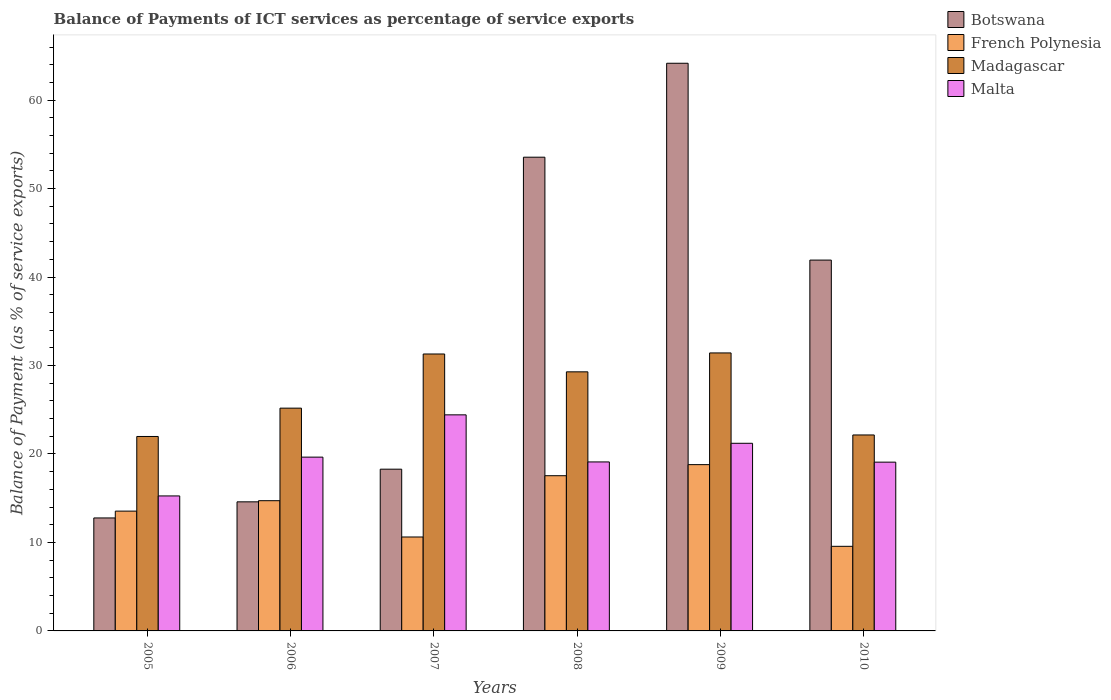How many different coloured bars are there?
Ensure brevity in your answer.  4. How many groups of bars are there?
Ensure brevity in your answer.  6. Are the number of bars per tick equal to the number of legend labels?
Provide a short and direct response. Yes. Are the number of bars on each tick of the X-axis equal?
Keep it short and to the point. Yes. How many bars are there on the 3rd tick from the left?
Provide a short and direct response. 4. What is the label of the 4th group of bars from the left?
Keep it short and to the point. 2008. In how many cases, is the number of bars for a given year not equal to the number of legend labels?
Offer a terse response. 0. What is the balance of payments of ICT services in Malta in 2007?
Ensure brevity in your answer.  24.42. Across all years, what is the maximum balance of payments of ICT services in Botswana?
Provide a short and direct response. 64.16. Across all years, what is the minimum balance of payments of ICT services in Madagascar?
Ensure brevity in your answer.  21.98. In which year was the balance of payments of ICT services in Madagascar minimum?
Provide a short and direct response. 2005. What is the total balance of payments of ICT services in French Polynesia in the graph?
Provide a short and direct response. 84.78. What is the difference between the balance of payments of ICT services in Botswana in 2005 and that in 2008?
Provide a short and direct response. -40.77. What is the difference between the balance of payments of ICT services in Botswana in 2008 and the balance of payments of ICT services in Malta in 2005?
Offer a very short reply. 38.29. What is the average balance of payments of ICT services in Madagascar per year?
Ensure brevity in your answer.  26.89. In the year 2006, what is the difference between the balance of payments of ICT services in Madagascar and balance of payments of ICT services in Botswana?
Your answer should be compact. 10.59. What is the ratio of the balance of payments of ICT services in Malta in 2005 to that in 2008?
Your answer should be very brief. 0.8. What is the difference between the highest and the second highest balance of payments of ICT services in Botswana?
Your answer should be very brief. 10.62. What is the difference between the highest and the lowest balance of payments of ICT services in Botswana?
Keep it short and to the point. 51.39. In how many years, is the balance of payments of ICT services in French Polynesia greater than the average balance of payments of ICT services in French Polynesia taken over all years?
Make the answer very short. 3. Is the sum of the balance of payments of ICT services in French Polynesia in 2007 and 2009 greater than the maximum balance of payments of ICT services in Botswana across all years?
Your response must be concise. No. What does the 1st bar from the left in 2007 represents?
Make the answer very short. Botswana. What does the 3rd bar from the right in 2005 represents?
Give a very brief answer. French Polynesia. How many bars are there?
Your answer should be very brief. 24. Are all the bars in the graph horizontal?
Provide a succinct answer. No. How many years are there in the graph?
Keep it short and to the point. 6. What is the difference between two consecutive major ticks on the Y-axis?
Ensure brevity in your answer.  10. Does the graph contain any zero values?
Make the answer very short. No. How are the legend labels stacked?
Provide a succinct answer. Vertical. What is the title of the graph?
Your answer should be very brief. Balance of Payments of ICT services as percentage of service exports. Does "Turks and Caicos Islands" appear as one of the legend labels in the graph?
Your answer should be compact. No. What is the label or title of the Y-axis?
Ensure brevity in your answer.  Balance of Payment (as % of service exports). What is the Balance of Payment (as % of service exports) of Botswana in 2005?
Your response must be concise. 12.77. What is the Balance of Payment (as % of service exports) of French Polynesia in 2005?
Provide a succinct answer. 13.54. What is the Balance of Payment (as % of service exports) of Madagascar in 2005?
Your answer should be very brief. 21.98. What is the Balance of Payment (as % of service exports) of Malta in 2005?
Make the answer very short. 15.26. What is the Balance of Payment (as % of service exports) of Botswana in 2006?
Your response must be concise. 14.59. What is the Balance of Payment (as % of service exports) in French Polynesia in 2006?
Your response must be concise. 14.72. What is the Balance of Payment (as % of service exports) in Madagascar in 2006?
Offer a very short reply. 25.18. What is the Balance of Payment (as % of service exports) in Malta in 2006?
Your answer should be compact. 19.64. What is the Balance of Payment (as % of service exports) of Botswana in 2007?
Give a very brief answer. 18.28. What is the Balance of Payment (as % of service exports) of French Polynesia in 2007?
Your answer should be compact. 10.62. What is the Balance of Payment (as % of service exports) of Madagascar in 2007?
Provide a short and direct response. 31.3. What is the Balance of Payment (as % of service exports) of Malta in 2007?
Your response must be concise. 24.42. What is the Balance of Payment (as % of service exports) in Botswana in 2008?
Provide a succinct answer. 53.54. What is the Balance of Payment (as % of service exports) of French Polynesia in 2008?
Provide a short and direct response. 17.54. What is the Balance of Payment (as % of service exports) in Madagascar in 2008?
Your answer should be very brief. 29.28. What is the Balance of Payment (as % of service exports) of Malta in 2008?
Offer a very short reply. 19.1. What is the Balance of Payment (as % of service exports) in Botswana in 2009?
Ensure brevity in your answer.  64.16. What is the Balance of Payment (as % of service exports) of French Polynesia in 2009?
Your answer should be compact. 18.8. What is the Balance of Payment (as % of service exports) in Madagascar in 2009?
Your answer should be compact. 31.42. What is the Balance of Payment (as % of service exports) in Malta in 2009?
Your answer should be very brief. 21.21. What is the Balance of Payment (as % of service exports) in Botswana in 2010?
Make the answer very short. 41.92. What is the Balance of Payment (as % of service exports) in French Polynesia in 2010?
Your response must be concise. 9.56. What is the Balance of Payment (as % of service exports) of Madagascar in 2010?
Offer a very short reply. 22.15. What is the Balance of Payment (as % of service exports) in Malta in 2010?
Offer a terse response. 19.08. Across all years, what is the maximum Balance of Payment (as % of service exports) of Botswana?
Provide a succinct answer. 64.16. Across all years, what is the maximum Balance of Payment (as % of service exports) of French Polynesia?
Your answer should be very brief. 18.8. Across all years, what is the maximum Balance of Payment (as % of service exports) in Madagascar?
Provide a short and direct response. 31.42. Across all years, what is the maximum Balance of Payment (as % of service exports) in Malta?
Your response must be concise. 24.42. Across all years, what is the minimum Balance of Payment (as % of service exports) in Botswana?
Provide a short and direct response. 12.77. Across all years, what is the minimum Balance of Payment (as % of service exports) in French Polynesia?
Your answer should be very brief. 9.56. Across all years, what is the minimum Balance of Payment (as % of service exports) of Madagascar?
Your answer should be compact. 21.98. Across all years, what is the minimum Balance of Payment (as % of service exports) of Malta?
Your answer should be compact. 15.26. What is the total Balance of Payment (as % of service exports) of Botswana in the graph?
Your response must be concise. 205.26. What is the total Balance of Payment (as % of service exports) of French Polynesia in the graph?
Offer a terse response. 84.78. What is the total Balance of Payment (as % of service exports) of Madagascar in the graph?
Your answer should be very brief. 161.31. What is the total Balance of Payment (as % of service exports) in Malta in the graph?
Provide a succinct answer. 118.71. What is the difference between the Balance of Payment (as % of service exports) in Botswana in 2005 and that in 2006?
Offer a very short reply. -1.82. What is the difference between the Balance of Payment (as % of service exports) of French Polynesia in 2005 and that in 2006?
Keep it short and to the point. -1.18. What is the difference between the Balance of Payment (as % of service exports) in Madagascar in 2005 and that in 2006?
Keep it short and to the point. -3.2. What is the difference between the Balance of Payment (as % of service exports) in Malta in 2005 and that in 2006?
Your response must be concise. -4.39. What is the difference between the Balance of Payment (as % of service exports) in Botswana in 2005 and that in 2007?
Keep it short and to the point. -5.51. What is the difference between the Balance of Payment (as % of service exports) in French Polynesia in 2005 and that in 2007?
Give a very brief answer. 2.92. What is the difference between the Balance of Payment (as % of service exports) of Madagascar in 2005 and that in 2007?
Ensure brevity in your answer.  -9.32. What is the difference between the Balance of Payment (as % of service exports) in Malta in 2005 and that in 2007?
Your answer should be compact. -9.16. What is the difference between the Balance of Payment (as % of service exports) in Botswana in 2005 and that in 2008?
Keep it short and to the point. -40.77. What is the difference between the Balance of Payment (as % of service exports) in French Polynesia in 2005 and that in 2008?
Provide a succinct answer. -4. What is the difference between the Balance of Payment (as % of service exports) in Madagascar in 2005 and that in 2008?
Your answer should be very brief. -7.31. What is the difference between the Balance of Payment (as % of service exports) in Malta in 2005 and that in 2008?
Your answer should be very brief. -3.84. What is the difference between the Balance of Payment (as % of service exports) of Botswana in 2005 and that in 2009?
Ensure brevity in your answer.  -51.39. What is the difference between the Balance of Payment (as % of service exports) of French Polynesia in 2005 and that in 2009?
Give a very brief answer. -5.26. What is the difference between the Balance of Payment (as % of service exports) of Madagascar in 2005 and that in 2009?
Offer a terse response. -9.44. What is the difference between the Balance of Payment (as % of service exports) in Malta in 2005 and that in 2009?
Your answer should be compact. -5.95. What is the difference between the Balance of Payment (as % of service exports) of Botswana in 2005 and that in 2010?
Ensure brevity in your answer.  -29.15. What is the difference between the Balance of Payment (as % of service exports) of French Polynesia in 2005 and that in 2010?
Your answer should be very brief. 3.98. What is the difference between the Balance of Payment (as % of service exports) of Madagascar in 2005 and that in 2010?
Ensure brevity in your answer.  -0.17. What is the difference between the Balance of Payment (as % of service exports) in Malta in 2005 and that in 2010?
Keep it short and to the point. -3.82. What is the difference between the Balance of Payment (as % of service exports) in Botswana in 2006 and that in 2007?
Ensure brevity in your answer.  -3.69. What is the difference between the Balance of Payment (as % of service exports) in French Polynesia in 2006 and that in 2007?
Your response must be concise. 4.1. What is the difference between the Balance of Payment (as % of service exports) in Madagascar in 2006 and that in 2007?
Offer a very short reply. -6.12. What is the difference between the Balance of Payment (as % of service exports) in Malta in 2006 and that in 2007?
Offer a very short reply. -4.78. What is the difference between the Balance of Payment (as % of service exports) in Botswana in 2006 and that in 2008?
Your response must be concise. -38.95. What is the difference between the Balance of Payment (as % of service exports) of French Polynesia in 2006 and that in 2008?
Your answer should be very brief. -2.82. What is the difference between the Balance of Payment (as % of service exports) of Madagascar in 2006 and that in 2008?
Provide a succinct answer. -4.1. What is the difference between the Balance of Payment (as % of service exports) in Malta in 2006 and that in 2008?
Your answer should be compact. 0.54. What is the difference between the Balance of Payment (as % of service exports) of Botswana in 2006 and that in 2009?
Offer a terse response. -49.57. What is the difference between the Balance of Payment (as % of service exports) of French Polynesia in 2006 and that in 2009?
Your answer should be compact. -4.08. What is the difference between the Balance of Payment (as % of service exports) of Madagascar in 2006 and that in 2009?
Keep it short and to the point. -6.24. What is the difference between the Balance of Payment (as % of service exports) of Malta in 2006 and that in 2009?
Your answer should be compact. -1.56. What is the difference between the Balance of Payment (as % of service exports) of Botswana in 2006 and that in 2010?
Provide a succinct answer. -27.33. What is the difference between the Balance of Payment (as % of service exports) of French Polynesia in 2006 and that in 2010?
Offer a terse response. 5.16. What is the difference between the Balance of Payment (as % of service exports) in Madagascar in 2006 and that in 2010?
Make the answer very short. 3.03. What is the difference between the Balance of Payment (as % of service exports) in Malta in 2006 and that in 2010?
Offer a terse response. 0.57. What is the difference between the Balance of Payment (as % of service exports) in Botswana in 2007 and that in 2008?
Offer a terse response. -35.26. What is the difference between the Balance of Payment (as % of service exports) in French Polynesia in 2007 and that in 2008?
Your answer should be very brief. -6.93. What is the difference between the Balance of Payment (as % of service exports) in Madagascar in 2007 and that in 2008?
Your response must be concise. 2.02. What is the difference between the Balance of Payment (as % of service exports) of Malta in 2007 and that in 2008?
Your answer should be very brief. 5.32. What is the difference between the Balance of Payment (as % of service exports) of Botswana in 2007 and that in 2009?
Offer a terse response. -45.88. What is the difference between the Balance of Payment (as % of service exports) of French Polynesia in 2007 and that in 2009?
Offer a very short reply. -8.18. What is the difference between the Balance of Payment (as % of service exports) of Madagascar in 2007 and that in 2009?
Offer a very short reply. -0.12. What is the difference between the Balance of Payment (as % of service exports) of Malta in 2007 and that in 2009?
Make the answer very short. 3.21. What is the difference between the Balance of Payment (as % of service exports) of Botswana in 2007 and that in 2010?
Your answer should be very brief. -23.63. What is the difference between the Balance of Payment (as % of service exports) of French Polynesia in 2007 and that in 2010?
Provide a short and direct response. 1.05. What is the difference between the Balance of Payment (as % of service exports) in Madagascar in 2007 and that in 2010?
Keep it short and to the point. 9.15. What is the difference between the Balance of Payment (as % of service exports) of Malta in 2007 and that in 2010?
Make the answer very short. 5.35. What is the difference between the Balance of Payment (as % of service exports) of Botswana in 2008 and that in 2009?
Your response must be concise. -10.62. What is the difference between the Balance of Payment (as % of service exports) of French Polynesia in 2008 and that in 2009?
Provide a succinct answer. -1.25. What is the difference between the Balance of Payment (as % of service exports) of Madagascar in 2008 and that in 2009?
Offer a terse response. -2.14. What is the difference between the Balance of Payment (as % of service exports) in Malta in 2008 and that in 2009?
Provide a short and direct response. -2.11. What is the difference between the Balance of Payment (as % of service exports) of Botswana in 2008 and that in 2010?
Offer a very short reply. 11.63. What is the difference between the Balance of Payment (as % of service exports) of French Polynesia in 2008 and that in 2010?
Make the answer very short. 7.98. What is the difference between the Balance of Payment (as % of service exports) of Madagascar in 2008 and that in 2010?
Provide a succinct answer. 7.13. What is the difference between the Balance of Payment (as % of service exports) of Malta in 2008 and that in 2010?
Offer a terse response. 0.03. What is the difference between the Balance of Payment (as % of service exports) in Botswana in 2009 and that in 2010?
Provide a short and direct response. 22.25. What is the difference between the Balance of Payment (as % of service exports) in French Polynesia in 2009 and that in 2010?
Offer a very short reply. 9.23. What is the difference between the Balance of Payment (as % of service exports) in Madagascar in 2009 and that in 2010?
Give a very brief answer. 9.27. What is the difference between the Balance of Payment (as % of service exports) of Malta in 2009 and that in 2010?
Make the answer very short. 2.13. What is the difference between the Balance of Payment (as % of service exports) in Botswana in 2005 and the Balance of Payment (as % of service exports) in French Polynesia in 2006?
Your response must be concise. -1.95. What is the difference between the Balance of Payment (as % of service exports) of Botswana in 2005 and the Balance of Payment (as % of service exports) of Madagascar in 2006?
Offer a very short reply. -12.41. What is the difference between the Balance of Payment (as % of service exports) in Botswana in 2005 and the Balance of Payment (as % of service exports) in Malta in 2006?
Offer a terse response. -6.87. What is the difference between the Balance of Payment (as % of service exports) in French Polynesia in 2005 and the Balance of Payment (as % of service exports) in Madagascar in 2006?
Your answer should be very brief. -11.64. What is the difference between the Balance of Payment (as % of service exports) in French Polynesia in 2005 and the Balance of Payment (as % of service exports) in Malta in 2006?
Your response must be concise. -6.1. What is the difference between the Balance of Payment (as % of service exports) in Madagascar in 2005 and the Balance of Payment (as % of service exports) in Malta in 2006?
Give a very brief answer. 2.33. What is the difference between the Balance of Payment (as % of service exports) in Botswana in 2005 and the Balance of Payment (as % of service exports) in French Polynesia in 2007?
Ensure brevity in your answer.  2.15. What is the difference between the Balance of Payment (as % of service exports) in Botswana in 2005 and the Balance of Payment (as % of service exports) in Madagascar in 2007?
Give a very brief answer. -18.53. What is the difference between the Balance of Payment (as % of service exports) in Botswana in 2005 and the Balance of Payment (as % of service exports) in Malta in 2007?
Make the answer very short. -11.65. What is the difference between the Balance of Payment (as % of service exports) in French Polynesia in 2005 and the Balance of Payment (as % of service exports) in Madagascar in 2007?
Make the answer very short. -17.76. What is the difference between the Balance of Payment (as % of service exports) of French Polynesia in 2005 and the Balance of Payment (as % of service exports) of Malta in 2007?
Your response must be concise. -10.88. What is the difference between the Balance of Payment (as % of service exports) in Madagascar in 2005 and the Balance of Payment (as % of service exports) in Malta in 2007?
Offer a terse response. -2.44. What is the difference between the Balance of Payment (as % of service exports) in Botswana in 2005 and the Balance of Payment (as % of service exports) in French Polynesia in 2008?
Provide a succinct answer. -4.77. What is the difference between the Balance of Payment (as % of service exports) of Botswana in 2005 and the Balance of Payment (as % of service exports) of Madagascar in 2008?
Provide a short and direct response. -16.51. What is the difference between the Balance of Payment (as % of service exports) of Botswana in 2005 and the Balance of Payment (as % of service exports) of Malta in 2008?
Make the answer very short. -6.33. What is the difference between the Balance of Payment (as % of service exports) of French Polynesia in 2005 and the Balance of Payment (as % of service exports) of Madagascar in 2008?
Provide a short and direct response. -15.74. What is the difference between the Balance of Payment (as % of service exports) of French Polynesia in 2005 and the Balance of Payment (as % of service exports) of Malta in 2008?
Provide a short and direct response. -5.56. What is the difference between the Balance of Payment (as % of service exports) of Madagascar in 2005 and the Balance of Payment (as % of service exports) of Malta in 2008?
Offer a terse response. 2.88. What is the difference between the Balance of Payment (as % of service exports) of Botswana in 2005 and the Balance of Payment (as % of service exports) of French Polynesia in 2009?
Your answer should be compact. -6.03. What is the difference between the Balance of Payment (as % of service exports) of Botswana in 2005 and the Balance of Payment (as % of service exports) of Madagascar in 2009?
Your answer should be very brief. -18.65. What is the difference between the Balance of Payment (as % of service exports) of Botswana in 2005 and the Balance of Payment (as % of service exports) of Malta in 2009?
Your answer should be compact. -8.44. What is the difference between the Balance of Payment (as % of service exports) in French Polynesia in 2005 and the Balance of Payment (as % of service exports) in Madagascar in 2009?
Keep it short and to the point. -17.88. What is the difference between the Balance of Payment (as % of service exports) of French Polynesia in 2005 and the Balance of Payment (as % of service exports) of Malta in 2009?
Keep it short and to the point. -7.67. What is the difference between the Balance of Payment (as % of service exports) of Madagascar in 2005 and the Balance of Payment (as % of service exports) of Malta in 2009?
Ensure brevity in your answer.  0.77. What is the difference between the Balance of Payment (as % of service exports) in Botswana in 2005 and the Balance of Payment (as % of service exports) in French Polynesia in 2010?
Provide a succinct answer. 3.21. What is the difference between the Balance of Payment (as % of service exports) of Botswana in 2005 and the Balance of Payment (as % of service exports) of Madagascar in 2010?
Provide a succinct answer. -9.38. What is the difference between the Balance of Payment (as % of service exports) in Botswana in 2005 and the Balance of Payment (as % of service exports) in Malta in 2010?
Your response must be concise. -6.31. What is the difference between the Balance of Payment (as % of service exports) of French Polynesia in 2005 and the Balance of Payment (as % of service exports) of Madagascar in 2010?
Offer a terse response. -8.61. What is the difference between the Balance of Payment (as % of service exports) of French Polynesia in 2005 and the Balance of Payment (as % of service exports) of Malta in 2010?
Offer a terse response. -5.54. What is the difference between the Balance of Payment (as % of service exports) of Madagascar in 2005 and the Balance of Payment (as % of service exports) of Malta in 2010?
Offer a very short reply. 2.9. What is the difference between the Balance of Payment (as % of service exports) of Botswana in 2006 and the Balance of Payment (as % of service exports) of French Polynesia in 2007?
Your answer should be compact. 3.97. What is the difference between the Balance of Payment (as % of service exports) of Botswana in 2006 and the Balance of Payment (as % of service exports) of Madagascar in 2007?
Offer a very short reply. -16.71. What is the difference between the Balance of Payment (as % of service exports) in Botswana in 2006 and the Balance of Payment (as % of service exports) in Malta in 2007?
Your response must be concise. -9.83. What is the difference between the Balance of Payment (as % of service exports) of French Polynesia in 2006 and the Balance of Payment (as % of service exports) of Madagascar in 2007?
Ensure brevity in your answer.  -16.58. What is the difference between the Balance of Payment (as % of service exports) of French Polynesia in 2006 and the Balance of Payment (as % of service exports) of Malta in 2007?
Make the answer very short. -9.7. What is the difference between the Balance of Payment (as % of service exports) in Madagascar in 2006 and the Balance of Payment (as % of service exports) in Malta in 2007?
Your answer should be very brief. 0.76. What is the difference between the Balance of Payment (as % of service exports) of Botswana in 2006 and the Balance of Payment (as % of service exports) of French Polynesia in 2008?
Keep it short and to the point. -2.95. What is the difference between the Balance of Payment (as % of service exports) of Botswana in 2006 and the Balance of Payment (as % of service exports) of Madagascar in 2008?
Ensure brevity in your answer.  -14.69. What is the difference between the Balance of Payment (as % of service exports) of Botswana in 2006 and the Balance of Payment (as % of service exports) of Malta in 2008?
Your answer should be compact. -4.51. What is the difference between the Balance of Payment (as % of service exports) of French Polynesia in 2006 and the Balance of Payment (as % of service exports) of Madagascar in 2008?
Offer a very short reply. -14.56. What is the difference between the Balance of Payment (as % of service exports) of French Polynesia in 2006 and the Balance of Payment (as % of service exports) of Malta in 2008?
Provide a short and direct response. -4.38. What is the difference between the Balance of Payment (as % of service exports) in Madagascar in 2006 and the Balance of Payment (as % of service exports) in Malta in 2008?
Keep it short and to the point. 6.08. What is the difference between the Balance of Payment (as % of service exports) in Botswana in 2006 and the Balance of Payment (as % of service exports) in French Polynesia in 2009?
Your answer should be very brief. -4.21. What is the difference between the Balance of Payment (as % of service exports) of Botswana in 2006 and the Balance of Payment (as % of service exports) of Madagascar in 2009?
Offer a very short reply. -16.83. What is the difference between the Balance of Payment (as % of service exports) of Botswana in 2006 and the Balance of Payment (as % of service exports) of Malta in 2009?
Ensure brevity in your answer.  -6.62. What is the difference between the Balance of Payment (as % of service exports) of French Polynesia in 2006 and the Balance of Payment (as % of service exports) of Madagascar in 2009?
Your response must be concise. -16.7. What is the difference between the Balance of Payment (as % of service exports) in French Polynesia in 2006 and the Balance of Payment (as % of service exports) in Malta in 2009?
Give a very brief answer. -6.49. What is the difference between the Balance of Payment (as % of service exports) in Madagascar in 2006 and the Balance of Payment (as % of service exports) in Malta in 2009?
Make the answer very short. 3.97. What is the difference between the Balance of Payment (as % of service exports) in Botswana in 2006 and the Balance of Payment (as % of service exports) in French Polynesia in 2010?
Your response must be concise. 5.03. What is the difference between the Balance of Payment (as % of service exports) of Botswana in 2006 and the Balance of Payment (as % of service exports) of Madagascar in 2010?
Your answer should be compact. -7.56. What is the difference between the Balance of Payment (as % of service exports) of Botswana in 2006 and the Balance of Payment (as % of service exports) of Malta in 2010?
Ensure brevity in your answer.  -4.49. What is the difference between the Balance of Payment (as % of service exports) of French Polynesia in 2006 and the Balance of Payment (as % of service exports) of Madagascar in 2010?
Provide a succinct answer. -7.43. What is the difference between the Balance of Payment (as % of service exports) of French Polynesia in 2006 and the Balance of Payment (as % of service exports) of Malta in 2010?
Your answer should be very brief. -4.36. What is the difference between the Balance of Payment (as % of service exports) of Madagascar in 2006 and the Balance of Payment (as % of service exports) of Malta in 2010?
Offer a very short reply. 6.1. What is the difference between the Balance of Payment (as % of service exports) in Botswana in 2007 and the Balance of Payment (as % of service exports) in French Polynesia in 2008?
Offer a very short reply. 0.74. What is the difference between the Balance of Payment (as % of service exports) in Botswana in 2007 and the Balance of Payment (as % of service exports) in Madagascar in 2008?
Offer a terse response. -11. What is the difference between the Balance of Payment (as % of service exports) in Botswana in 2007 and the Balance of Payment (as % of service exports) in Malta in 2008?
Offer a very short reply. -0.82. What is the difference between the Balance of Payment (as % of service exports) in French Polynesia in 2007 and the Balance of Payment (as % of service exports) in Madagascar in 2008?
Ensure brevity in your answer.  -18.67. What is the difference between the Balance of Payment (as % of service exports) in French Polynesia in 2007 and the Balance of Payment (as % of service exports) in Malta in 2008?
Keep it short and to the point. -8.49. What is the difference between the Balance of Payment (as % of service exports) in Madagascar in 2007 and the Balance of Payment (as % of service exports) in Malta in 2008?
Ensure brevity in your answer.  12.2. What is the difference between the Balance of Payment (as % of service exports) of Botswana in 2007 and the Balance of Payment (as % of service exports) of French Polynesia in 2009?
Your answer should be very brief. -0.51. What is the difference between the Balance of Payment (as % of service exports) in Botswana in 2007 and the Balance of Payment (as % of service exports) in Madagascar in 2009?
Offer a very short reply. -13.14. What is the difference between the Balance of Payment (as % of service exports) of Botswana in 2007 and the Balance of Payment (as % of service exports) of Malta in 2009?
Offer a terse response. -2.93. What is the difference between the Balance of Payment (as % of service exports) of French Polynesia in 2007 and the Balance of Payment (as % of service exports) of Madagascar in 2009?
Your response must be concise. -20.8. What is the difference between the Balance of Payment (as % of service exports) in French Polynesia in 2007 and the Balance of Payment (as % of service exports) in Malta in 2009?
Offer a very short reply. -10.59. What is the difference between the Balance of Payment (as % of service exports) of Madagascar in 2007 and the Balance of Payment (as % of service exports) of Malta in 2009?
Make the answer very short. 10.09. What is the difference between the Balance of Payment (as % of service exports) in Botswana in 2007 and the Balance of Payment (as % of service exports) in French Polynesia in 2010?
Provide a succinct answer. 8.72. What is the difference between the Balance of Payment (as % of service exports) in Botswana in 2007 and the Balance of Payment (as % of service exports) in Madagascar in 2010?
Make the answer very short. -3.87. What is the difference between the Balance of Payment (as % of service exports) in Botswana in 2007 and the Balance of Payment (as % of service exports) in Malta in 2010?
Keep it short and to the point. -0.8. What is the difference between the Balance of Payment (as % of service exports) of French Polynesia in 2007 and the Balance of Payment (as % of service exports) of Madagascar in 2010?
Keep it short and to the point. -11.53. What is the difference between the Balance of Payment (as % of service exports) of French Polynesia in 2007 and the Balance of Payment (as % of service exports) of Malta in 2010?
Make the answer very short. -8.46. What is the difference between the Balance of Payment (as % of service exports) in Madagascar in 2007 and the Balance of Payment (as % of service exports) in Malta in 2010?
Provide a short and direct response. 12.22. What is the difference between the Balance of Payment (as % of service exports) in Botswana in 2008 and the Balance of Payment (as % of service exports) in French Polynesia in 2009?
Offer a very short reply. 34.75. What is the difference between the Balance of Payment (as % of service exports) in Botswana in 2008 and the Balance of Payment (as % of service exports) in Madagascar in 2009?
Your answer should be compact. 22.12. What is the difference between the Balance of Payment (as % of service exports) in Botswana in 2008 and the Balance of Payment (as % of service exports) in Malta in 2009?
Give a very brief answer. 32.34. What is the difference between the Balance of Payment (as % of service exports) of French Polynesia in 2008 and the Balance of Payment (as % of service exports) of Madagascar in 2009?
Offer a very short reply. -13.88. What is the difference between the Balance of Payment (as % of service exports) in French Polynesia in 2008 and the Balance of Payment (as % of service exports) in Malta in 2009?
Make the answer very short. -3.66. What is the difference between the Balance of Payment (as % of service exports) of Madagascar in 2008 and the Balance of Payment (as % of service exports) of Malta in 2009?
Give a very brief answer. 8.08. What is the difference between the Balance of Payment (as % of service exports) in Botswana in 2008 and the Balance of Payment (as % of service exports) in French Polynesia in 2010?
Provide a succinct answer. 43.98. What is the difference between the Balance of Payment (as % of service exports) of Botswana in 2008 and the Balance of Payment (as % of service exports) of Madagascar in 2010?
Make the answer very short. 31.39. What is the difference between the Balance of Payment (as % of service exports) of Botswana in 2008 and the Balance of Payment (as % of service exports) of Malta in 2010?
Offer a very short reply. 34.47. What is the difference between the Balance of Payment (as % of service exports) of French Polynesia in 2008 and the Balance of Payment (as % of service exports) of Madagascar in 2010?
Offer a terse response. -4.61. What is the difference between the Balance of Payment (as % of service exports) in French Polynesia in 2008 and the Balance of Payment (as % of service exports) in Malta in 2010?
Ensure brevity in your answer.  -1.53. What is the difference between the Balance of Payment (as % of service exports) in Madagascar in 2008 and the Balance of Payment (as % of service exports) in Malta in 2010?
Your answer should be very brief. 10.21. What is the difference between the Balance of Payment (as % of service exports) of Botswana in 2009 and the Balance of Payment (as % of service exports) of French Polynesia in 2010?
Ensure brevity in your answer.  54.6. What is the difference between the Balance of Payment (as % of service exports) of Botswana in 2009 and the Balance of Payment (as % of service exports) of Madagascar in 2010?
Make the answer very short. 42.01. What is the difference between the Balance of Payment (as % of service exports) of Botswana in 2009 and the Balance of Payment (as % of service exports) of Malta in 2010?
Offer a very short reply. 45.09. What is the difference between the Balance of Payment (as % of service exports) of French Polynesia in 2009 and the Balance of Payment (as % of service exports) of Madagascar in 2010?
Give a very brief answer. -3.35. What is the difference between the Balance of Payment (as % of service exports) of French Polynesia in 2009 and the Balance of Payment (as % of service exports) of Malta in 2010?
Provide a short and direct response. -0.28. What is the difference between the Balance of Payment (as % of service exports) in Madagascar in 2009 and the Balance of Payment (as % of service exports) in Malta in 2010?
Keep it short and to the point. 12.34. What is the average Balance of Payment (as % of service exports) in Botswana per year?
Provide a succinct answer. 34.21. What is the average Balance of Payment (as % of service exports) in French Polynesia per year?
Offer a very short reply. 14.13. What is the average Balance of Payment (as % of service exports) of Madagascar per year?
Give a very brief answer. 26.89. What is the average Balance of Payment (as % of service exports) in Malta per year?
Your answer should be compact. 19.79. In the year 2005, what is the difference between the Balance of Payment (as % of service exports) in Botswana and Balance of Payment (as % of service exports) in French Polynesia?
Offer a very short reply. -0.77. In the year 2005, what is the difference between the Balance of Payment (as % of service exports) of Botswana and Balance of Payment (as % of service exports) of Madagascar?
Offer a terse response. -9.21. In the year 2005, what is the difference between the Balance of Payment (as % of service exports) in Botswana and Balance of Payment (as % of service exports) in Malta?
Provide a short and direct response. -2.49. In the year 2005, what is the difference between the Balance of Payment (as % of service exports) in French Polynesia and Balance of Payment (as % of service exports) in Madagascar?
Keep it short and to the point. -8.44. In the year 2005, what is the difference between the Balance of Payment (as % of service exports) of French Polynesia and Balance of Payment (as % of service exports) of Malta?
Offer a very short reply. -1.72. In the year 2005, what is the difference between the Balance of Payment (as % of service exports) of Madagascar and Balance of Payment (as % of service exports) of Malta?
Keep it short and to the point. 6.72. In the year 2006, what is the difference between the Balance of Payment (as % of service exports) in Botswana and Balance of Payment (as % of service exports) in French Polynesia?
Offer a terse response. -0.13. In the year 2006, what is the difference between the Balance of Payment (as % of service exports) in Botswana and Balance of Payment (as % of service exports) in Madagascar?
Ensure brevity in your answer.  -10.59. In the year 2006, what is the difference between the Balance of Payment (as % of service exports) in Botswana and Balance of Payment (as % of service exports) in Malta?
Give a very brief answer. -5.05. In the year 2006, what is the difference between the Balance of Payment (as % of service exports) of French Polynesia and Balance of Payment (as % of service exports) of Madagascar?
Your response must be concise. -10.46. In the year 2006, what is the difference between the Balance of Payment (as % of service exports) of French Polynesia and Balance of Payment (as % of service exports) of Malta?
Offer a terse response. -4.92. In the year 2006, what is the difference between the Balance of Payment (as % of service exports) of Madagascar and Balance of Payment (as % of service exports) of Malta?
Provide a short and direct response. 5.54. In the year 2007, what is the difference between the Balance of Payment (as % of service exports) in Botswana and Balance of Payment (as % of service exports) in French Polynesia?
Give a very brief answer. 7.67. In the year 2007, what is the difference between the Balance of Payment (as % of service exports) in Botswana and Balance of Payment (as % of service exports) in Madagascar?
Keep it short and to the point. -13.02. In the year 2007, what is the difference between the Balance of Payment (as % of service exports) in Botswana and Balance of Payment (as % of service exports) in Malta?
Provide a short and direct response. -6.14. In the year 2007, what is the difference between the Balance of Payment (as % of service exports) in French Polynesia and Balance of Payment (as % of service exports) in Madagascar?
Your answer should be compact. -20.69. In the year 2007, what is the difference between the Balance of Payment (as % of service exports) of French Polynesia and Balance of Payment (as % of service exports) of Malta?
Offer a terse response. -13.81. In the year 2007, what is the difference between the Balance of Payment (as % of service exports) of Madagascar and Balance of Payment (as % of service exports) of Malta?
Provide a short and direct response. 6.88. In the year 2008, what is the difference between the Balance of Payment (as % of service exports) in Botswana and Balance of Payment (as % of service exports) in French Polynesia?
Give a very brief answer. 36. In the year 2008, what is the difference between the Balance of Payment (as % of service exports) of Botswana and Balance of Payment (as % of service exports) of Madagascar?
Provide a short and direct response. 24.26. In the year 2008, what is the difference between the Balance of Payment (as % of service exports) of Botswana and Balance of Payment (as % of service exports) of Malta?
Provide a short and direct response. 34.44. In the year 2008, what is the difference between the Balance of Payment (as % of service exports) in French Polynesia and Balance of Payment (as % of service exports) in Madagascar?
Ensure brevity in your answer.  -11.74. In the year 2008, what is the difference between the Balance of Payment (as % of service exports) in French Polynesia and Balance of Payment (as % of service exports) in Malta?
Your answer should be compact. -1.56. In the year 2008, what is the difference between the Balance of Payment (as % of service exports) of Madagascar and Balance of Payment (as % of service exports) of Malta?
Provide a succinct answer. 10.18. In the year 2009, what is the difference between the Balance of Payment (as % of service exports) of Botswana and Balance of Payment (as % of service exports) of French Polynesia?
Your response must be concise. 45.37. In the year 2009, what is the difference between the Balance of Payment (as % of service exports) in Botswana and Balance of Payment (as % of service exports) in Madagascar?
Your answer should be very brief. 32.74. In the year 2009, what is the difference between the Balance of Payment (as % of service exports) in Botswana and Balance of Payment (as % of service exports) in Malta?
Your answer should be compact. 42.95. In the year 2009, what is the difference between the Balance of Payment (as % of service exports) in French Polynesia and Balance of Payment (as % of service exports) in Madagascar?
Offer a very short reply. -12.62. In the year 2009, what is the difference between the Balance of Payment (as % of service exports) in French Polynesia and Balance of Payment (as % of service exports) in Malta?
Provide a succinct answer. -2.41. In the year 2009, what is the difference between the Balance of Payment (as % of service exports) of Madagascar and Balance of Payment (as % of service exports) of Malta?
Keep it short and to the point. 10.21. In the year 2010, what is the difference between the Balance of Payment (as % of service exports) of Botswana and Balance of Payment (as % of service exports) of French Polynesia?
Offer a very short reply. 32.35. In the year 2010, what is the difference between the Balance of Payment (as % of service exports) in Botswana and Balance of Payment (as % of service exports) in Madagascar?
Your answer should be compact. 19.77. In the year 2010, what is the difference between the Balance of Payment (as % of service exports) of Botswana and Balance of Payment (as % of service exports) of Malta?
Ensure brevity in your answer.  22.84. In the year 2010, what is the difference between the Balance of Payment (as % of service exports) in French Polynesia and Balance of Payment (as % of service exports) in Madagascar?
Offer a very short reply. -12.59. In the year 2010, what is the difference between the Balance of Payment (as % of service exports) in French Polynesia and Balance of Payment (as % of service exports) in Malta?
Offer a very short reply. -9.51. In the year 2010, what is the difference between the Balance of Payment (as % of service exports) in Madagascar and Balance of Payment (as % of service exports) in Malta?
Offer a very short reply. 3.07. What is the ratio of the Balance of Payment (as % of service exports) in Botswana in 2005 to that in 2006?
Offer a very short reply. 0.88. What is the ratio of the Balance of Payment (as % of service exports) in French Polynesia in 2005 to that in 2006?
Ensure brevity in your answer.  0.92. What is the ratio of the Balance of Payment (as % of service exports) in Madagascar in 2005 to that in 2006?
Your answer should be very brief. 0.87. What is the ratio of the Balance of Payment (as % of service exports) in Malta in 2005 to that in 2006?
Keep it short and to the point. 0.78. What is the ratio of the Balance of Payment (as % of service exports) in Botswana in 2005 to that in 2007?
Ensure brevity in your answer.  0.7. What is the ratio of the Balance of Payment (as % of service exports) of French Polynesia in 2005 to that in 2007?
Keep it short and to the point. 1.28. What is the ratio of the Balance of Payment (as % of service exports) in Madagascar in 2005 to that in 2007?
Keep it short and to the point. 0.7. What is the ratio of the Balance of Payment (as % of service exports) in Malta in 2005 to that in 2007?
Ensure brevity in your answer.  0.62. What is the ratio of the Balance of Payment (as % of service exports) of Botswana in 2005 to that in 2008?
Make the answer very short. 0.24. What is the ratio of the Balance of Payment (as % of service exports) in French Polynesia in 2005 to that in 2008?
Make the answer very short. 0.77. What is the ratio of the Balance of Payment (as % of service exports) of Madagascar in 2005 to that in 2008?
Provide a short and direct response. 0.75. What is the ratio of the Balance of Payment (as % of service exports) of Malta in 2005 to that in 2008?
Ensure brevity in your answer.  0.8. What is the ratio of the Balance of Payment (as % of service exports) of Botswana in 2005 to that in 2009?
Your response must be concise. 0.2. What is the ratio of the Balance of Payment (as % of service exports) of French Polynesia in 2005 to that in 2009?
Your response must be concise. 0.72. What is the ratio of the Balance of Payment (as % of service exports) in Madagascar in 2005 to that in 2009?
Make the answer very short. 0.7. What is the ratio of the Balance of Payment (as % of service exports) in Malta in 2005 to that in 2009?
Offer a terse response. 0.72. What is the ratio of the Balance of Payment (as % of service exports) in Botswana in 2005 to that in 2010?
Your answer should be very brief. 0.3. What is the ratio of the Balance of Payment (as % of service exports) in French Polynesia in 2005 to that in 2010?
Provide a short and direct response. 1.42. What is the ratio of the Balance of Payment (as % of service exports) in Malta in 2005 to that in 2010?
Offer a very short reply. 0.8. What is the ratio of the Balance of Payment (as % of service exports) of Botswana in 2006 to that in 2007?
Your answer should be compact. 0.8. What is the ratio of the Balance of Payment (as % of service exports) of French Polynesia in 2006 to that in 2007?
Your answer should be very brief. 1.39. What is the ratio of the Balance of Payment (as % of service exports) of Madagascar in 2006 to that in 2007?
Your answer should be very brief. 0.8. What is the ratio of the Balance of Payment (as % of service exports) of Malta in 2006 to that in 2007?
Offer a very short reply. 0.8. What is the ratio of the Balance of Payment (as % of service exports) of Botswana in 2006 to that in 2008?
Make the answer very short. 0.27. What is the ratio of the Balance of Payment (as % of service exports) of French Polynesia in 2006 to that in 2008?
Offer a very short reply. 0.84. What is the ratio of the Balance of Payment (as % of service exports) of Madagascar in 2006 to that in 2008?
Your answer should be very brief. 0.86. What is the ratio of the Balance of Payment (as % of service exports) of Malta in 2006 to that in 2008?
Offer a very short reply. 1.03. What is the ratio of the Balance of Payment (as % of service exports) of Botswana in 2006 to that in 2009?
Offer a very short reply. 0.23. What is the ratio of the Balance of Payment (as % of service exports) in French Polynesia in 2006 to that in 2009?
Your answer should be very brief. 0.78. What is the ratio of the Balance of Payment (as % of service exports) of Madagascar in 2006 to that in 2009?
Ensure brevity in your answer.  0.8. What is the ratio of the Balance of Payment (as % of service exports) of Malta in 2006 to that in 2009?
Give a very brief answer. 0.93. What is the ratio of the Balance of Payment (as % of service exports) in Botswana in 2006 to that in 2010?
Your response must be concise. 0.35. What is the ratio of the Balance of Payment (as % of service exports) in French Polynesia in 2006 to that in 2010?
Your answer should be compact. 1.54. What is the ratio of the Balance of Payment (as % of service exports) in Madagascar in 2006 to that in 2010?
Give a very brief answer. 1.14. What is the ratio of the Balance of Payment (as % of service exports) in Malta in 2006 to that in 2010?
Provide a succinct answer. 1.03. What is the ratio of the Balance of Payment (as % of service exports) of Botswana in 2007 to that in 2008?
Keep it short and to the point. 0.34. What is the ratio of the Balance of Payment (as % of service exports) in French Polynesia in 2007 to that in 2008?
Give a very brief answer. 0.61. What is the ratio of the Balance of Payment (as % of service exports) of Madagascar in 2007 to that in 2008?
Make the answer very short. 1.07. What is the ratio of the Balance of Payment (as % of service exports) in Malta in 2007 to that in 2008?
Provide a short and direct response. 1.28. What is the ratio of the Balance of Payment (as % of service exports) in Botswana in 2007 to that in 2009?
Your answer should be compact. 0.28. What is the ratio of the Balance of Payment (as % of service exports) in French Polynesia in 2007 to that in 2009?
Your answer should be compact. 0.56. What is the ratio of the Balance of Payment (as % of service exports) in Malta in 2007 to that in 2009?
Ensure brevity in your answer.  1.15. What is the ratio of the Balance of Payment (as % of service exports) in Botswana in 2007 to that in 2010?
Offer a terse response. 0.44. What is the ratio of the Balance of Payment (as % of service exports) in French Polynesia in 2007 to that in 2010?
Offer a terse response. 1.11. What is the ratio of the Balance of Payment (as % of service exports) in Madagascar in 2007 to that in 2010?
Your answer should be compact. 1.41. What is the ratio of the Balance of Payment (as % of service exports) of Malta in 2007 to that in 2010?
Offer a very short reply. 1.28. What is the ratio of the Balance of Payment (as % of service exports) of Botswana in 2008 to that in 2009?
Ensure brevity in your answer.  0.83. What is the ratio of the Balance of Payment (as % of service exports) of French Polynesia in 2008 to that in 2009?
Your answer should be very brief. 0.93. What is the ratio of the Balance of Payment (as % of service exports) of Madagascar in 2008 to that in 2009?
Keep it short and to the point. 0.93. What is the ratio of the Balance of Payment (as % of service exports) in Malta in 2008 to that in 2009?
Offer a terse response. 0.9. What is the ratio of the Balance of Payment (as % of service exports) in Botswana in 2008 to that in 2010?
Offer a very short reply. 1.28. What is the ratio of the Balance of Payment (as % of service exports) of French Polynesia in 2008 to that in 2010?
Provide a succinct answer. 1.83. What is the ratio of the Balance of Payment (as % of service exports) in Madagascar in 2008 to that in 2010?
Provide a succinct answer. 1.32. What is the ratio of the Balance of Payment (as % of service exports) in Botswana in 2009 to that in 2010?
Keep it short and to the point. 1.53. What is the ratio of the Balance of Payment (as % of service exports) of French Polynesia in 2009 to that in 2010?
Your answer should be compact. 1.97. What is the ratio of the Balance of Payment (as % of service exports) of Madagascar in 2009 to that in 2010?
Make the answer very short. 1.42. What is the ratio of the Balance of Payment (as % of service exports) of Malta in 2009 to that in 2010?
Provide a succinct answer. 1.11. What is the difference between the highest and the second highest Balance of Payment (as % of service exports) in Botswana?
Ensure brevity in your answer.  10.62. What is the difference between the highest and the second highest Balance of Payment (as % of service exports) in French Polynesia?
Your answer should be very brief. 1.25. What is the difference between the highest and the second highest Balance of Payment (as % of service exports) in Madagascar?
Ensure brevity in your answer.  0.12. What is the difference between the highest and the second highest Balance of Payment (as % of service exports) of Malta?
Provide a succinct answer. 3.21. What is the difference between the highest and the lowest Balance of Payment (as % of service exports) in Botswana?
Your answer should be compact. 51.39. What is the difference between the highest and the lowest Balance of Payment (as % of service exports) in French Polynesia?
Your answer should be compact. 9.23. What is the difference between the highest and the lowest Balance of Payment (as % of service exports) in Madagascar?
Offer a terse response. 9.44. What is the difference between the highest and the lowest Balance of Payment (as % of service exports) in Malta?
Make the answer very short. 9.16. 